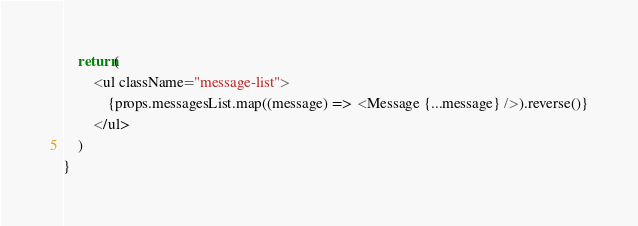<code> <loc_0><loc_0><loc_500><loc_500><_JavaScript_>    return(
        <ul className="message-list">
            {props.messagesList.map((message) => <Message {...message} />).reverse()}
        </ul>
    )
}
</code> 